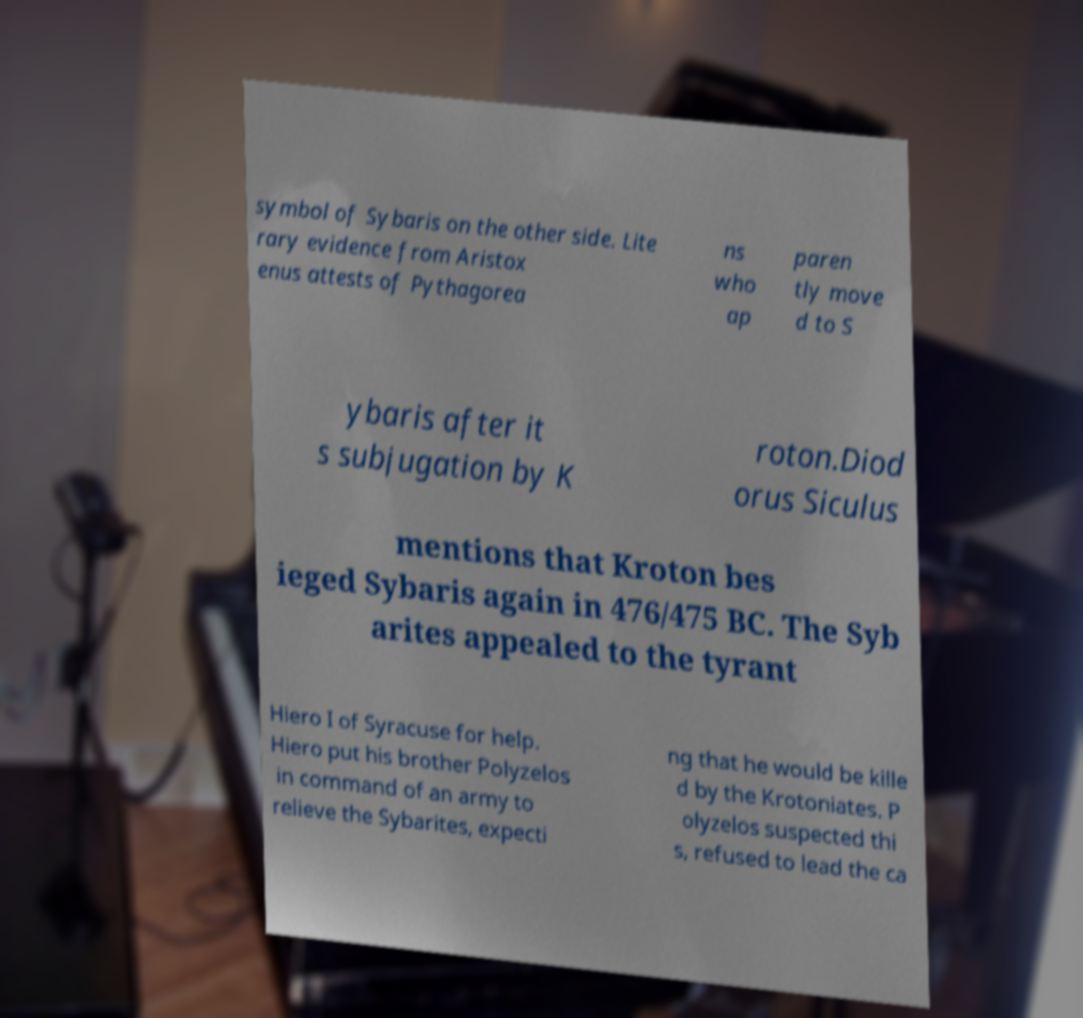Please identify and transcribe the text found in this image. symbol of Sybaris on the other side. Lite rary evidence from Aristox enus attests of Pythagorea ns who ap paren tly move d to S ybaris after it s subjugation by K roton.Diod orus Siculus mentions that Kroton bes ieged Sybaris again in 476/475 BC. The Syb arites appealed to the tyrant Hiero I of Syracuse for help. Hiero put his brother Polyzelos in command of an army to relieve the Sybarites, expecti ng that he would be kille d by the Krotoniates. P olyzelos suspected thi s, refused to lead the ca 